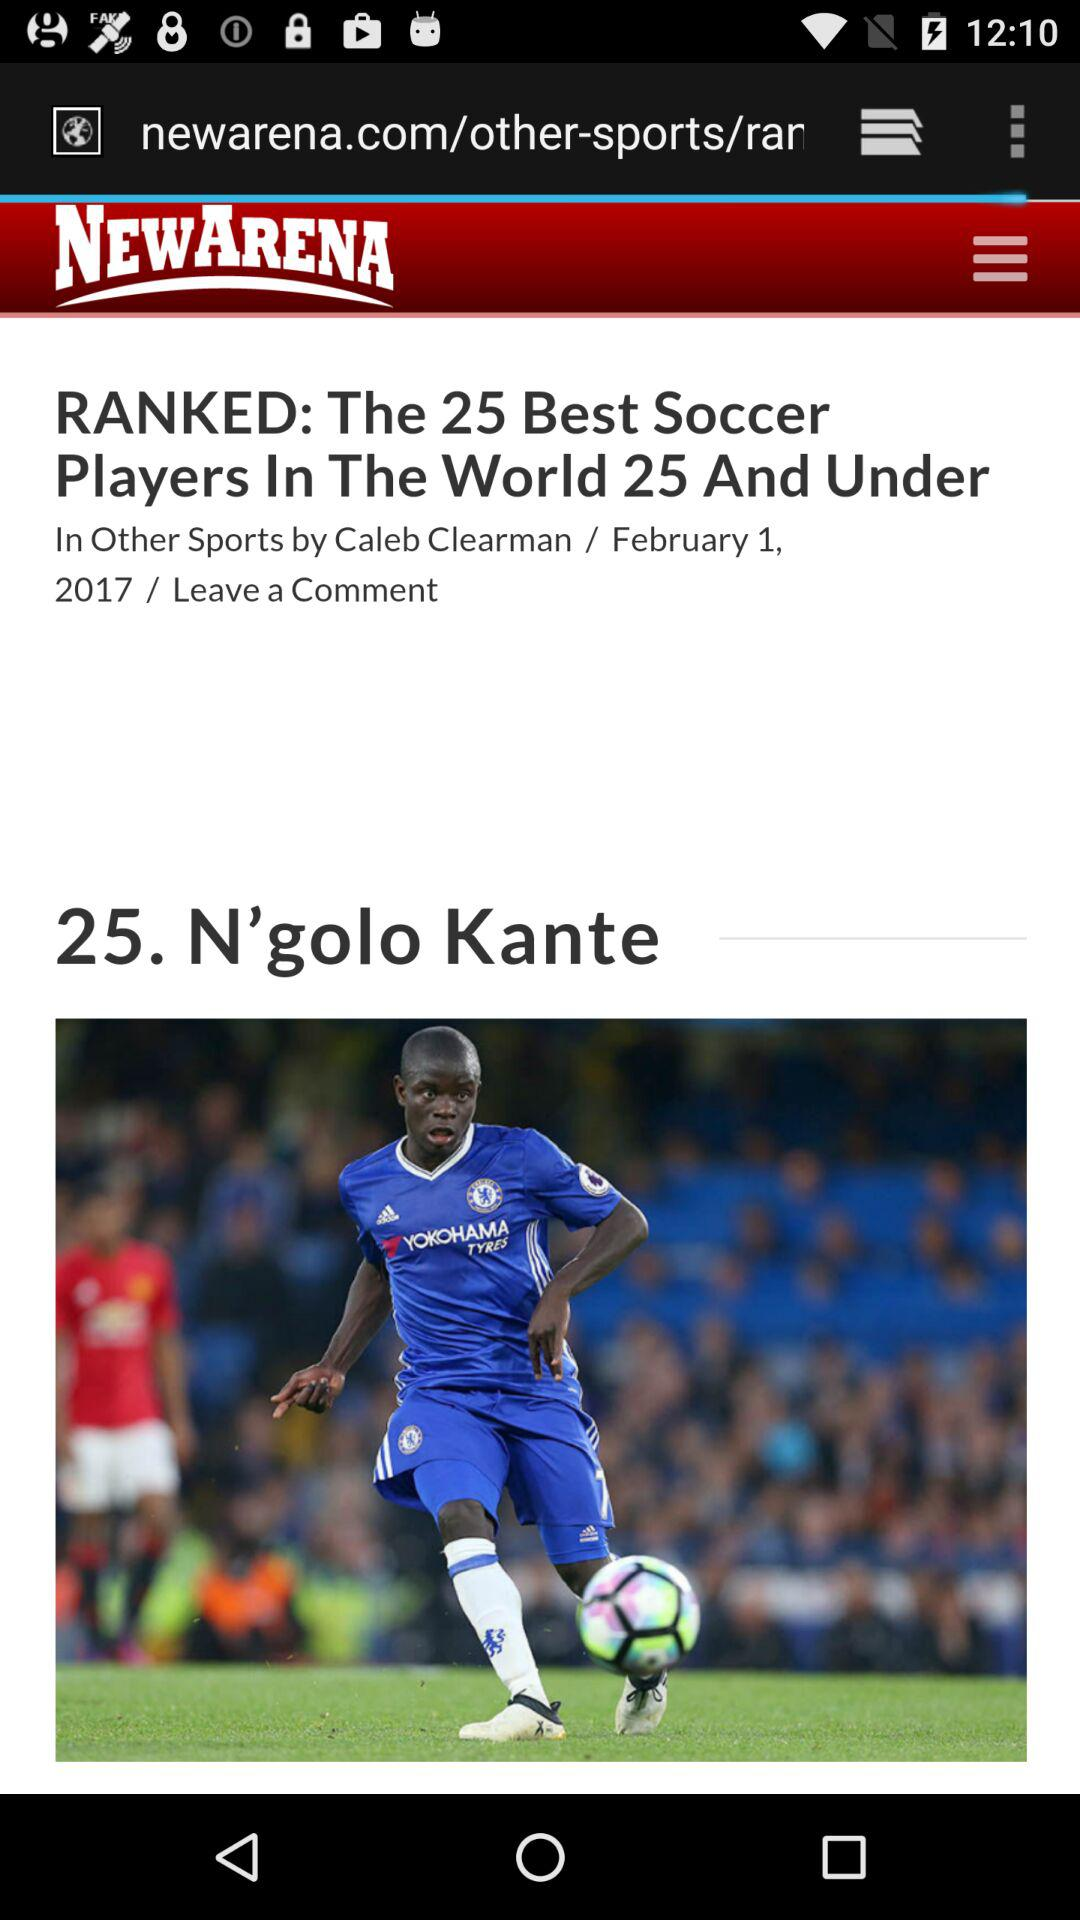Who is the author of the article? The author is Caleb Clearman. 